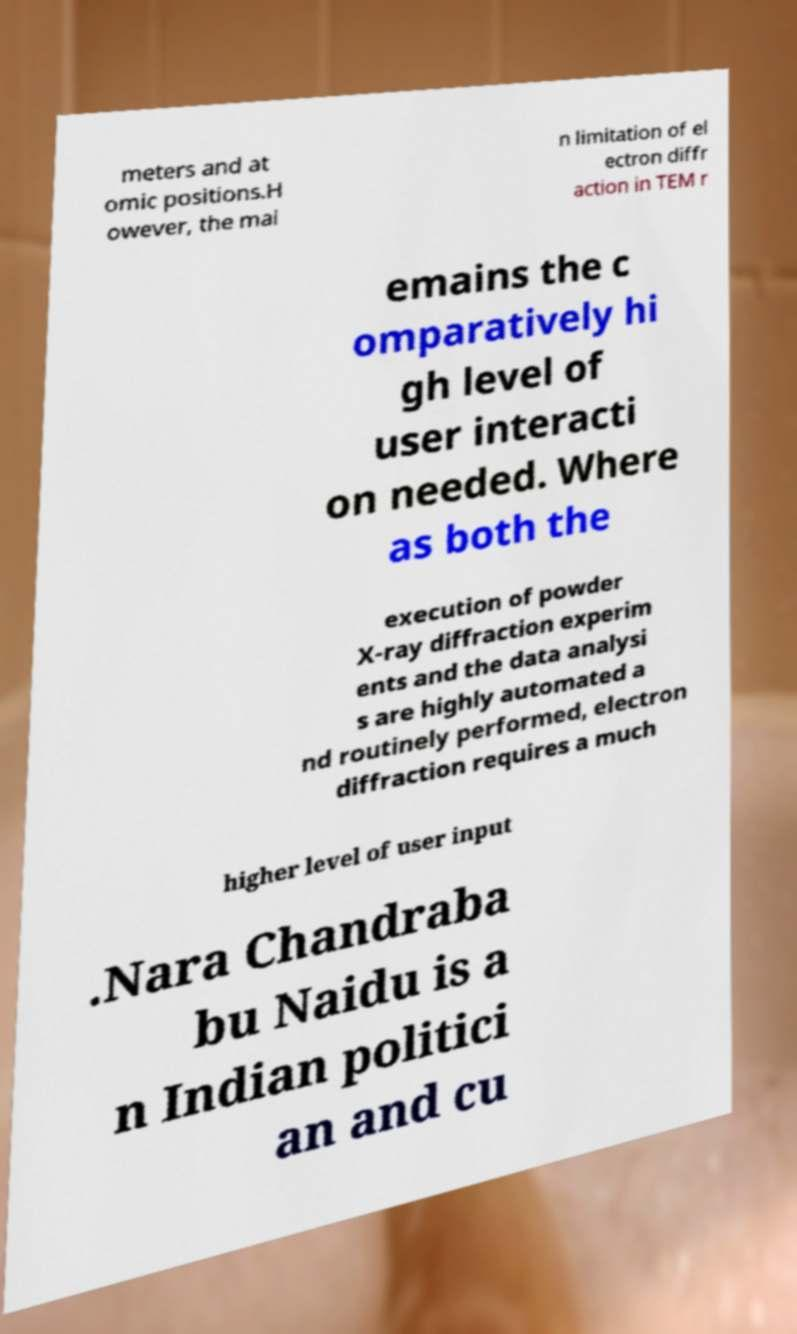Could you extract and type out the text from this image? meters and at omic positions.H owever, the mai n limitation of el ectron diffr action in TEM r emains the c omparatively hi gh level of user interacti on needed. Where as both the execution of powder X-ray diffraction experim ents and the data analysi s are highly automated a nd routinely performed, electron diffraction requires a much higher level of user input .Nara Chandraba bu Naidu is a n Indian politici an and cu 